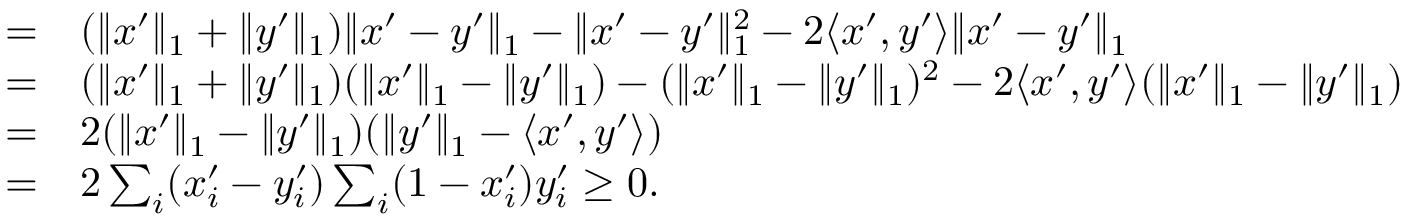Convert formula to latex. <formula><loc_0><loc_0><loc_500><loc_500>\begin{array} { r l } { = } & ( \| x ^ { \prime } \| _ { 1 } + \| y ^ { \prime } \| _ { 1 } ) \| x ^ { \prime } - y ^ { \prime } \| _ { 1 } - \| x ^ { \prime } - y ^ { \prime } \| _ { 1 } ^ { 2 } - 2 \langle x ^ { \prime } , y ^ { \prime } \rangle \| x ^ { \prime } - y ^ { \prime } \| _ { 1 } } \\ { = } & ( \| x ^ { \prime } \| _ { 1 } + \| y ^ { \prime } \| _ { 1 } ) ( \| x ^ { \prime } \| _ { 1 } - \| y ^ { \prime } \| _ { 1 } ) - ( \| x ^ { \prime } \| _ { 1 } - \| y ^ { \prime } \| _ { 1 } ) ^ { 2 } - 2 \langle x ^ { \prime } , y ^ { \prime } \rangle ( \| x ^ { \prime } \| _ { 1 } - \| y ^ { \prime } \| _ { 1 } ) } \\ { = } & 2 ( \| x ^ { \prime } \| _ { 1 } - \| y ^ { \prime } \| _ { 1 } ) ( \| y ^ { \prime } \| _ { 1 } - \langle x ^ { \prime } , y ^ { \prime } \rangle ) } \\ { = } & 2 \sum _ { i } ( x _ { i } ^ { \prime } - y _ { i } ^ { \prime } ) \sum _ { i } ( 1 - x _ { i } ^ { \prime } ) y _ { i } ^ { \prime } \geq 0 . } \end{array}</formula> 